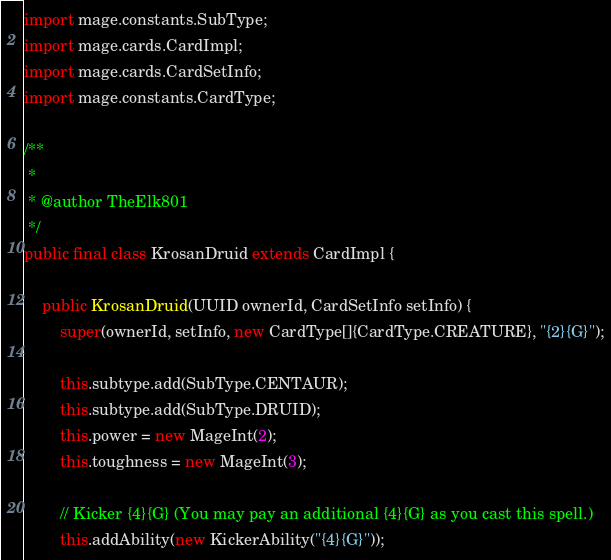<code> <loc_0><loc_0><loc_500><loc_500><_Java_>import mage.constants.SubType;
import mage.cards.CardImpl;
import mage.cards.CardSetInfo;
import mage.constants.CardType;

/**
 *
 * @author TheElk801
 */
public final class KrosanDruid extends CardImpl {

    public KrosanDruid(UUID ownerId, CardSetInfo setInfo) {
        super(ownerId, setInfo, new CardType[]{CardType.CREATURE}, "{2}{G}");

        this.subtype.add(SubType.CENTAUR);
        this.subtype.add(SubType.DRUID);
        this.power = new MageInt(2);
        this.toughness = new MageInt(3);

        // Kicker {4}{G} (You may pay an additional {4}{G} as you cast this spell.)
        this.addAbility(new KickerAbility("{4}{G}"));
</code> 